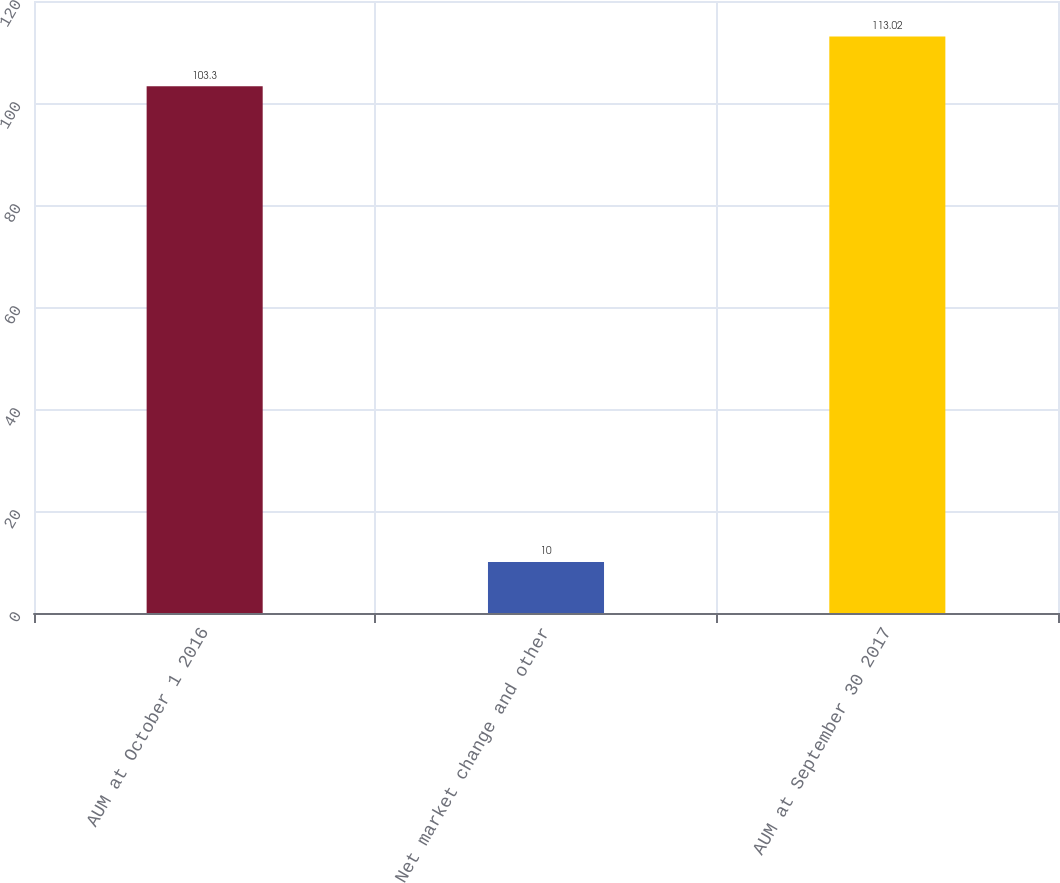Convert chart to OTSL. <chart><loc_0><loc_0><loc_500><loc_500><bar_chart><fcel>AUM at October 1 2016<fcel>Net market change and other<fcel>AUM at September 30 2017<nl><fcel>103.3<fcel>10<fcel>113.02<nl></chart> 